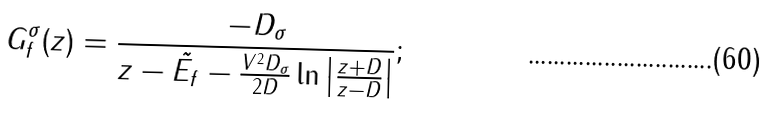Convert formula to latex. <formula><loc_0><loc_0><loc_500><loc_500>G _ { f } ^ { \sigma } ( z ) = \frac { - D _ { \sigma } } { z - \tilde { E _ { f } } - \frac { V ^ { 2 } D _ { \sigma } } { 2 D } \ln \left | \frac { z + D } { z - D } \right | } ;</formula> 